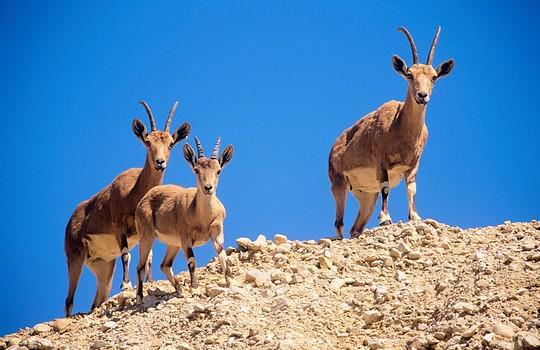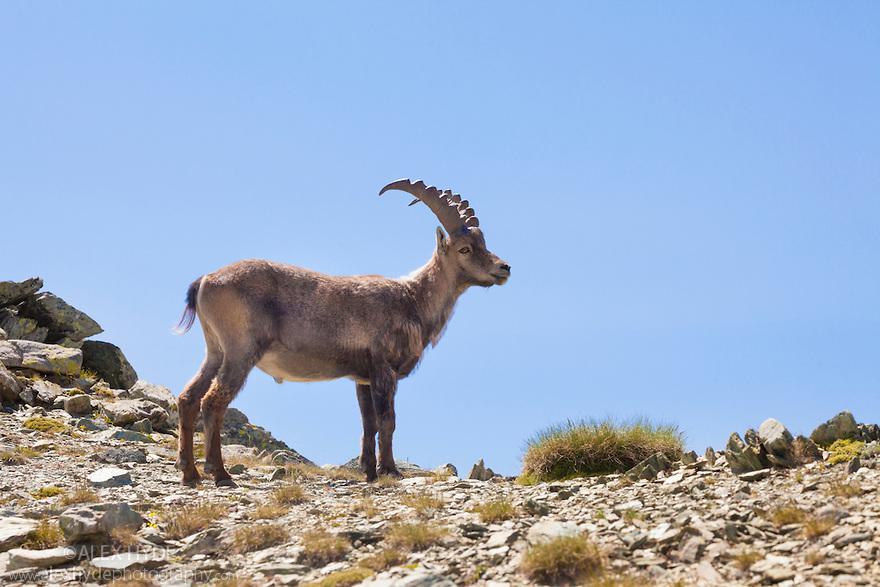The first image is the image on the left, the second image is the image on the right. Considering the images on both sides, is "Two rams are facing each other on top of a boulder in the mountains in one image." valid? Answer yes or no. No. The first image is the image on the left, the second image is the image on the right. Considering the images on both sides, is "In at least one image there is a lone Ibex on rocky ground" valid? Answer yes or no. Yes. 